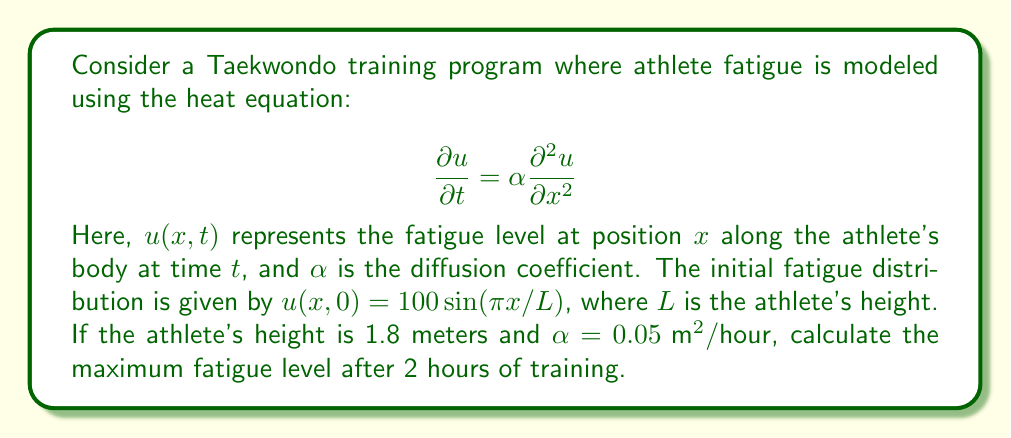Provide a solution to this math problem. To solve this problem, we need to use the solution to the heat equation with the given initial condition. The general solution for the heat equation with initial condition $u(x,0) = f(x)$ is:

$$u(x,t) = \sum_{n=1}^{\infty} B_n \sin\left(\frac{n\pi x}{L}\right) e^{-\alpha n^2 \pi^2 t / L^2}$$

where $B_n$ are the Fourier coefficients of the initial condition.

In our case, the initial condition is already in the form of a single sine term:

$$u(x,0) = 100 \sin(\pi x/L)$$

This means we only have one non-zero Fourier coefficient, $B_1 = 100$, and $n = 1$.

Substituting the given values:
$L = 1.8 \text{ m}$
$\alpha = 0.05 \text{ m}^2/\text{hour}$
$t = 2 \text{ hours}$

We can now write the solution as:

$$u(x,t) = 100 \sin\left(\frac{\pi x}{1.8}\right) e^{-0.05 \cdot \pi^2 \cdot 2 / 1.8^2}$$

To find the maximum fatigue level, we need to maximize this function with respect to $x$. The maximum of $\sin(\pi x/1.8)$ occurs at $x = 0.9 \text{ m}$ (half of the athlete's height), where the sine term equals 1.

Therefore, the maximum fatigue level is:

$$u_{\text{max}} = 100 \cdot e^{-0.05 \cdot \pi^2 \cdot 2 / 1.8^2}$$

Calculating this value:

$$u_{\text{max}} = 100 \cdot e^{-0.3054} \approx 73.69$$
Answer: The maximum fatigue level after 2 hours of training is approximately 73.69. 